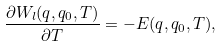<formula> <loc_0><loc_0><loc_500><loc_500>\frac { \partial W _ { l } ( q , q _ { 0 } , T ) } { \partial T } = - E ( q , q _ { 0 } , T ) ,</formula> 